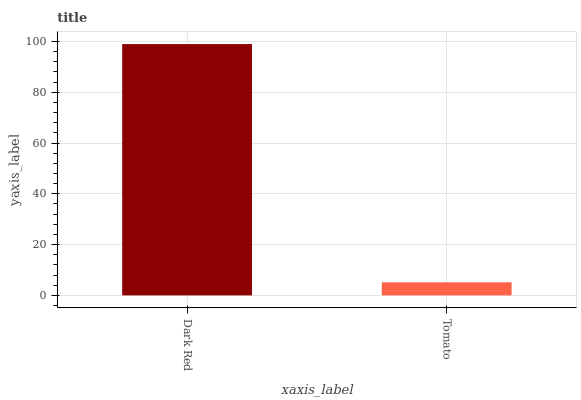Is Tomato the minimum?
Answer yes or no. Yes. Is Dark Red the maximum?
Answer yes or no. Yes. Is Tomato the maximum?
Answer yes or no. No. Is Dark Red greater than Tomato?
Answer yes or no. Yes. Is Tomato less than Dark Red?
Answer yes or no. Yes. Is Tomato greater than Dark Red?
Answer yes or no. No. Is Dark Red less than Tomato?
Answer yes or no. No. Is Dark Red the high median?
Answer yes or no. Yes. Is Tomato the low median?
Answer yes or no. Yes. Is Tomato the high median?
Answer yes or no. No. Is Dark Red the low median?
Answer yes or no. No. 